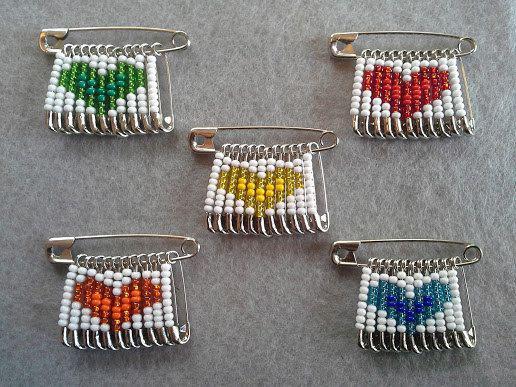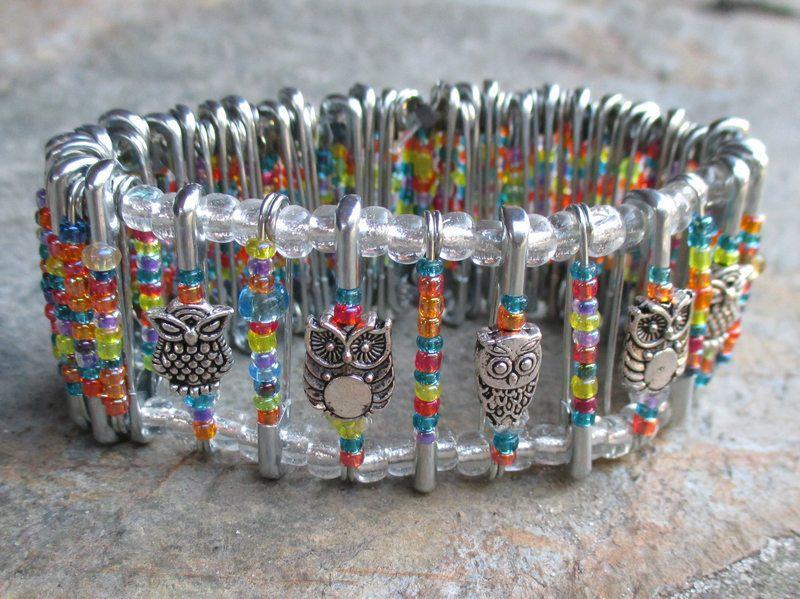The first image is the image on the left, the second image is the image on the right. For the images shown, is this caption "There are at least four pins in one of the images." true? Answer yes or no. Yes. The first image is the image on the left, the second image is the image on the right. Assess this claim about the two images: "An image shows only a bracelet made of safety pins strung with multicolored beads.". Correct or not? Answer yes or no. Yes. 